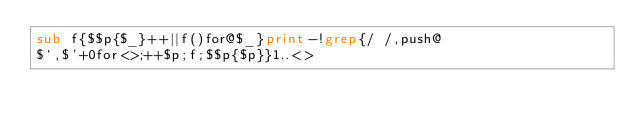<code> <loc_0><loc_0><loc_500><loc_500><_Perl_>sub f{$$p{$_}++||f()for@$_}print-!grep{/ /,push@
$`,$'+0for<>;++$p;f;$$p{$p}}1..<></code> 